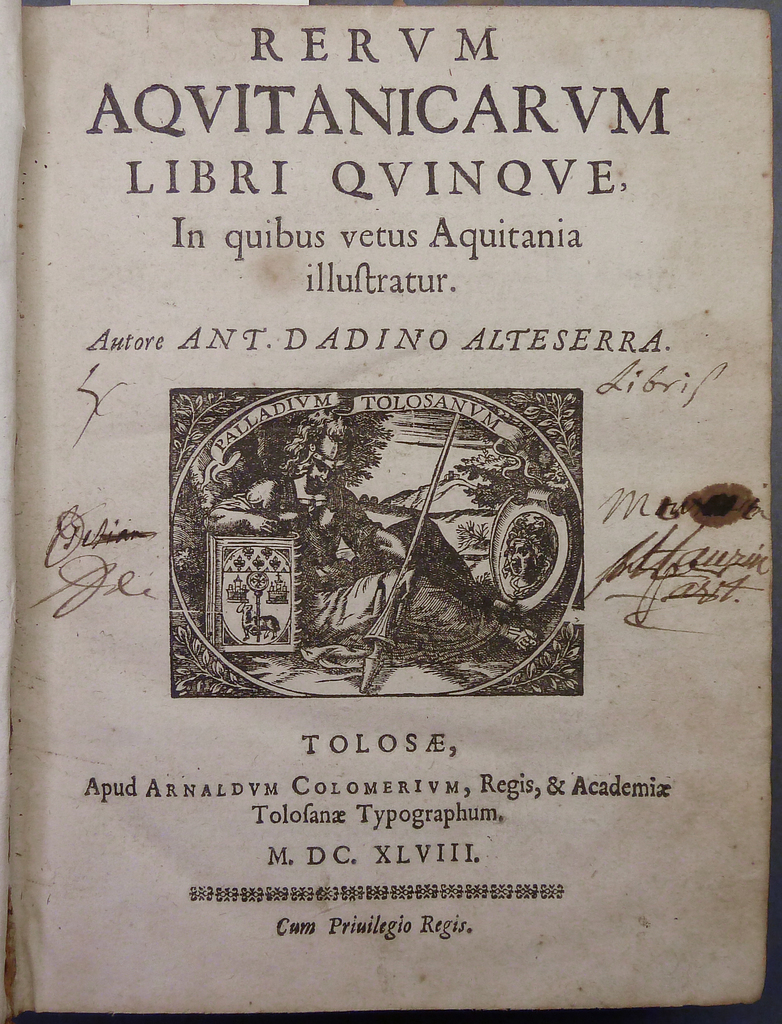Provide a one-sentence caption for the provided image.
Reference OCR token: RERVM, AQVITANICARVM, LIBRI, QVINQVE, In, quibus, vetus, Aquitania, illuftratur., Autore, ANT, ANT.DADINO, ALTESERRA., ADIVM, dibrif, PALL, Me, ge, laupi, TOLOSE,, Apud, ARNALDVM, CoL, COLOMERIVM,, OLOMERIVM,, Regis,, &, Academix, Tolofance, Typographum., M., DC., XLVIII, 83808618, *8, Cum, Priuilegio, Regis. A page from an ancient book showing RERUM written in Latin on the very top. 